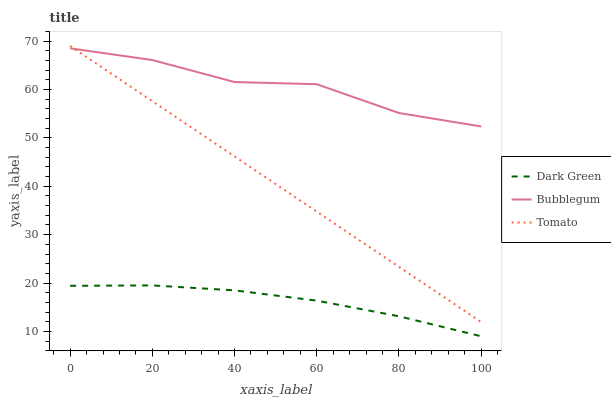Does Bubblegum have the minimum area under the curve?
Answer yes or no. No. Does Dark Green have the maximum area under the curve?
Answer yes or no. No. Is Dark Green the smoothest?
Answer yes or no. No. Is Dark Green the roughest?
Answer yes or no. No. Does Bubblegum have the lowest value?
Answer yes or no. No. Does Bubblegum have the highest value?
Answer yes or no. No. Is Dark Green less than Tomato?
Answer yes or no. Yes. Is Tomato greater than Dark Green?
Answer yes or no. Yes. Does Dark Green intersect Tomato?
Answer yes or no. No. 